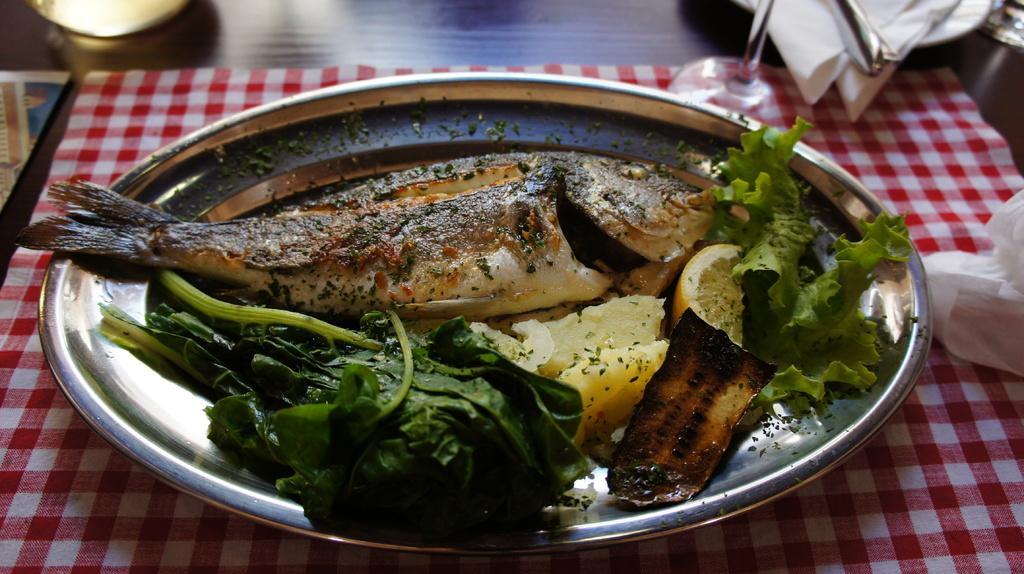Please provide a concise description of this image. In this image, we can see a table, on that table there is a red colored cloth, we can see a steel plate, there is a fish on the plate, we can see green vegetables on the plate. 